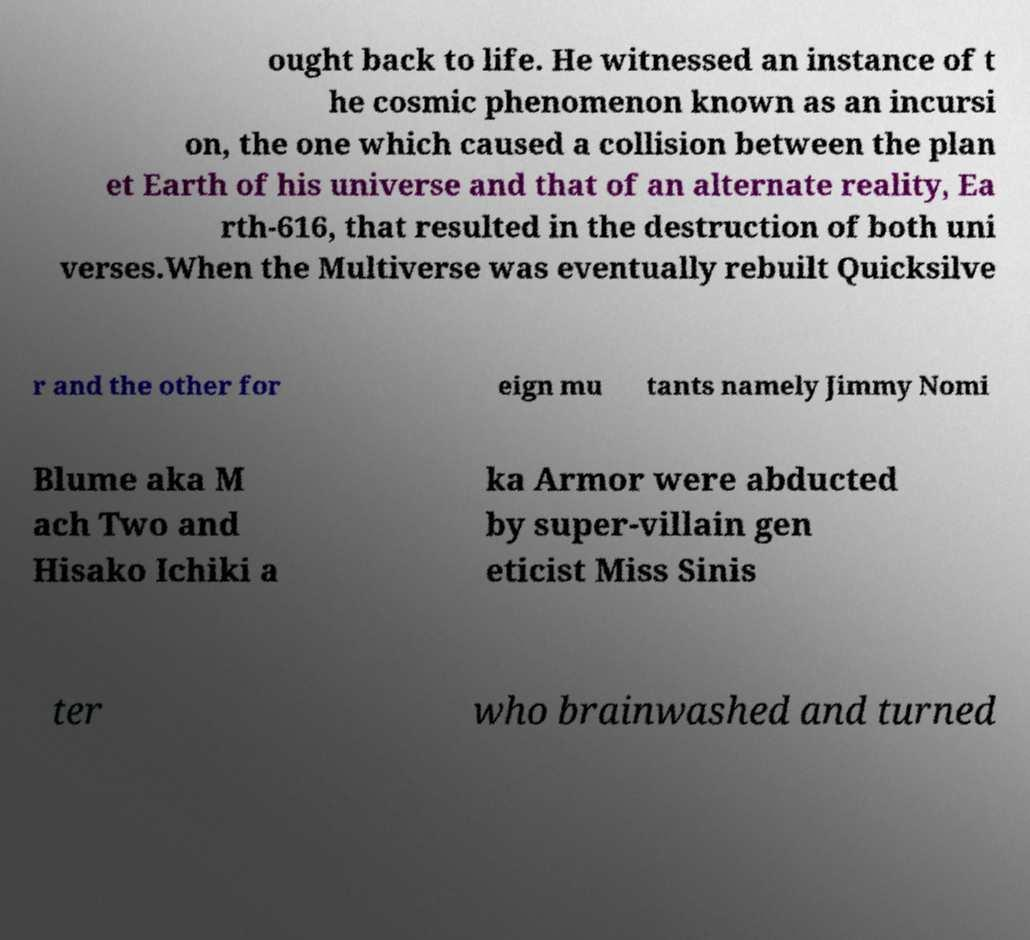I need the written content from this picture converted into text. Can you do that? ought back to life. He witnessed an instance of t he cosmic phenomenon known as an incursi on, the one which caused a collision between the plan et Earth of his universe and that of an alternate reality, Ea rth-616, that resulted in the destruction of both uni verses.When the Multiverse was eventually rebuilt Quicksilve r and the other for eign mu tants namely Jimmy Nomi Blume aka M ach Two and Hisako Ichiki a ka Armor were abducted by super-villain gen eticist Miss Sinis ter who brainwashed and turned 